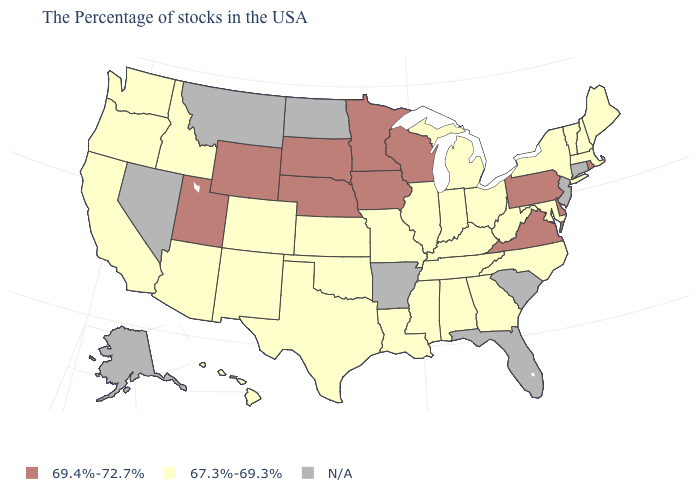Name the states that have a value in the range 67.3%-69.3%?
Quick response, please. Maine, Massachusetts, New Hampshire, Vermont, New York, Maryland, North Carolina, West Virginia, Ohio, Georgia, Michigan, Kentucky, Indiana, Alabama, Tennessee, Illinois, Mississippi, Louisiana, Missouri, Kansas, Oklahoma, Texas, Colorado, New Mexico, Arizona, Idaho, California, Washington, Oregon, Hawaii. Name the states that have a value in the range N/A?
Short answer required. Connecticut, New Jersey, South Carolina, Florida, Arkansas, North Dakota, Montana, Nevada, Alaska. Name the states that have a value in the range 67.3%-69.3%?
Keep it brief. Maine, Massachusetts, New Hampshire, Vermont, New York, Maryland, North Carolina, West Virginia, Ohio, Georgia, Michigan, Kentucky, Indiana, Alabama, Tennessee, Illinois, Mississippi, Louisiana, Missouri, Kansas, Oklahoma, Texas, Colorado, New Mexico, Arizona, Idaho, California, Washington, Oregon, Hawaii. Which states hav the highest value in the West?
Keep it brief. Wyoming, Utah. What is the value of Virginia?
Keep it brief. 69.4%-72.7%. Which states have the highest value in the USA?
Answer briefly. Rhode Island, Delaware, Pennsylvania, Virginia, Wisconsin, Minnesota, Iowa, Nebraska, South Dakota, Wyoming, Utah. How many symbols are there in the legend?
Quick response, please. 3. What is the value of California?
Give a very brief answer. 67.3%-69.3%. Name the states that have a value in the range N/A?
Concise answer only. Connecticut, New Jersey, South Carolina, Florida, Arkansas, North Dakota, Montana, Nevada, Alaska. Among the states that border Oklahoma , which have the highest value?
Write a very short answer. Missouri, Kansas, Texas, Colorado, New Mexico. Name the states that have a value in the range N/A?
Concise answer only. Connecticut, New Jersey, South Carolina, Florida, Arkansas, North Dakota, Montana, Nevada, Alaska. What is the value of Nebraska?
Write a very short answer. 69.4%-72.7%. 